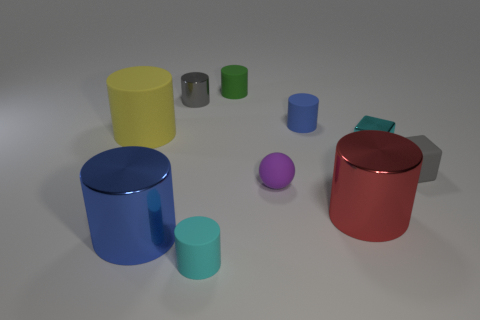Subtract all blue cylinders. How many cylinders are left? 5 Subtract all tiny cyan cylinders. How many cylinders are left? 6 Subtract all blue cylinders. Subtract all yellow cubes. How many cylinders are left? 5 Subtract all blocks. How many objects are left? 8 Add 7 purple spheres. How many purple spheres exist? 8 Subtract 0 brown spheres. How many objects are left? 10 Subtract all big red things. Subtract all gray metallic cylinders. How many objects are left? 8 Add 6 tiny green cylinders. How many tiny green cylinders are left? 7 